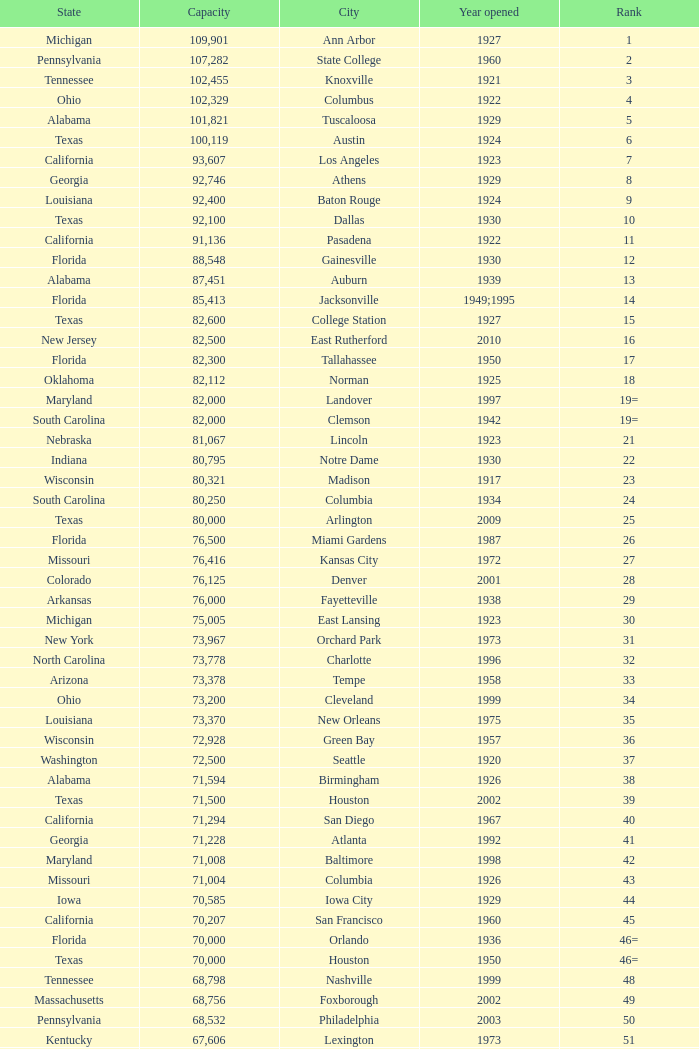What is the city in Alabama that opened in 1996? Huntsville. 